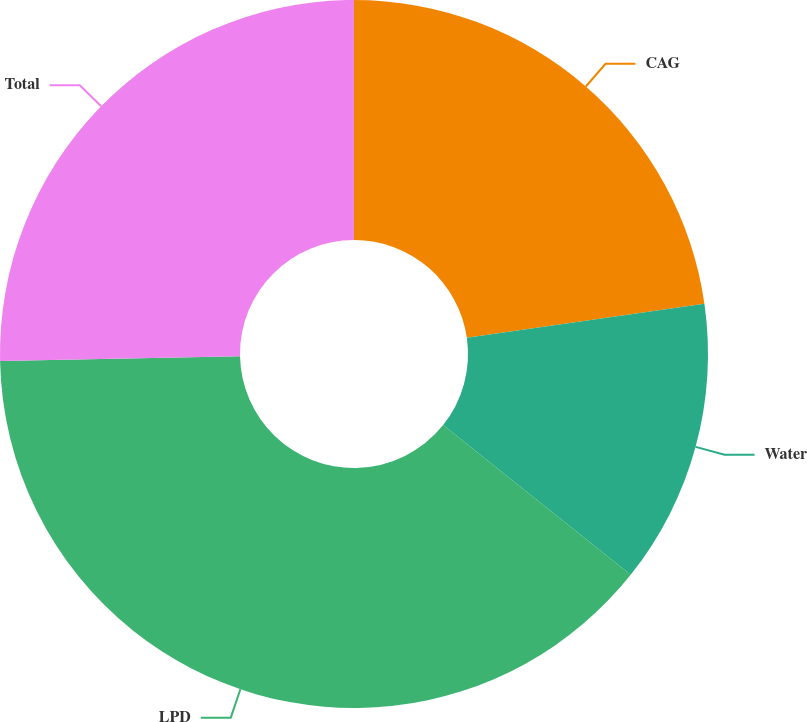<chart> <loc_0><loc_0><loc_500><loc_500><pie_chart><fcel>CAG<fcel>Water<fcel>LPD<fcel>Total<nl><fcel>22.73%<fcel>12.99%<fcel>38.96%<fcel>25.32%<nl></chart> 